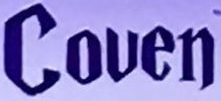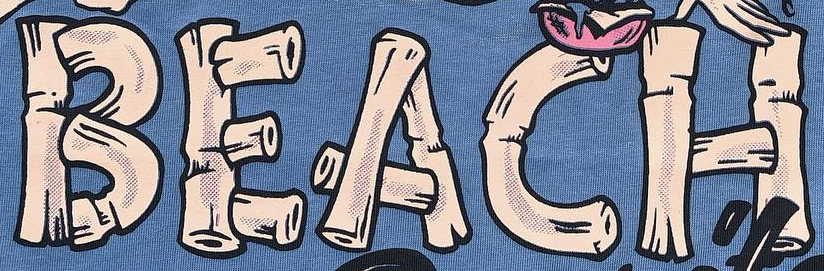What text appears in these images from left to right, separated by a semicolon? Couen; BEACH 